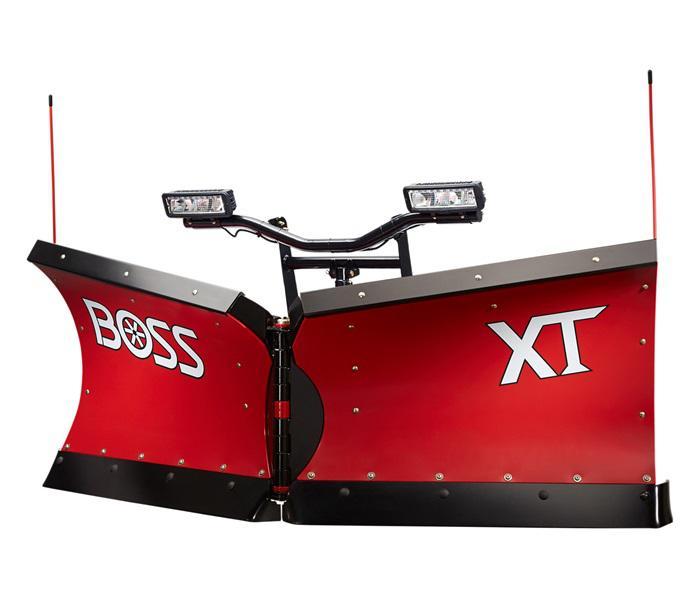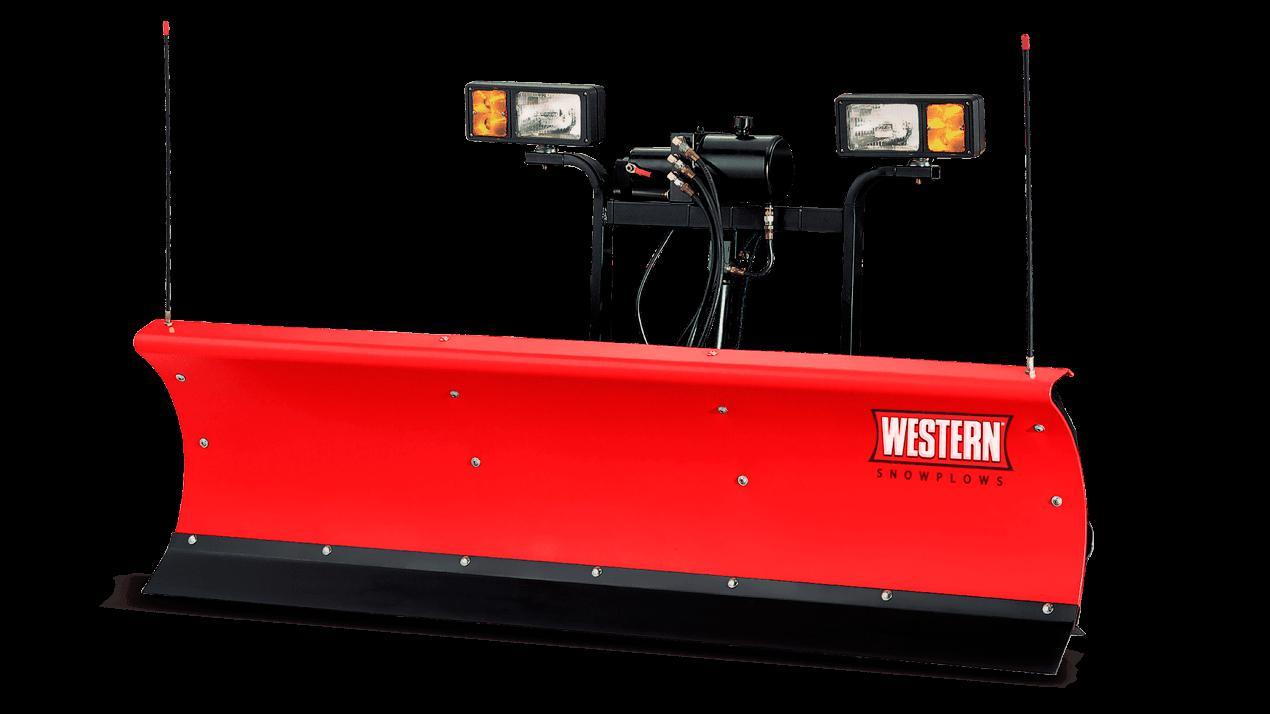The first image is the image on the left, the second image is the image on the right. Analyze the images presented: Is the assertion "In each image, a snow plow blade is shown with a pickup truck." valid? Answer yes or no. No. The first image is the image on the left, the second image is the image on the right. For the images shown, is this caption "There is exactly one scraper not attached to a vehicle in the image on the left" true? Answer yes or no. Yes. 